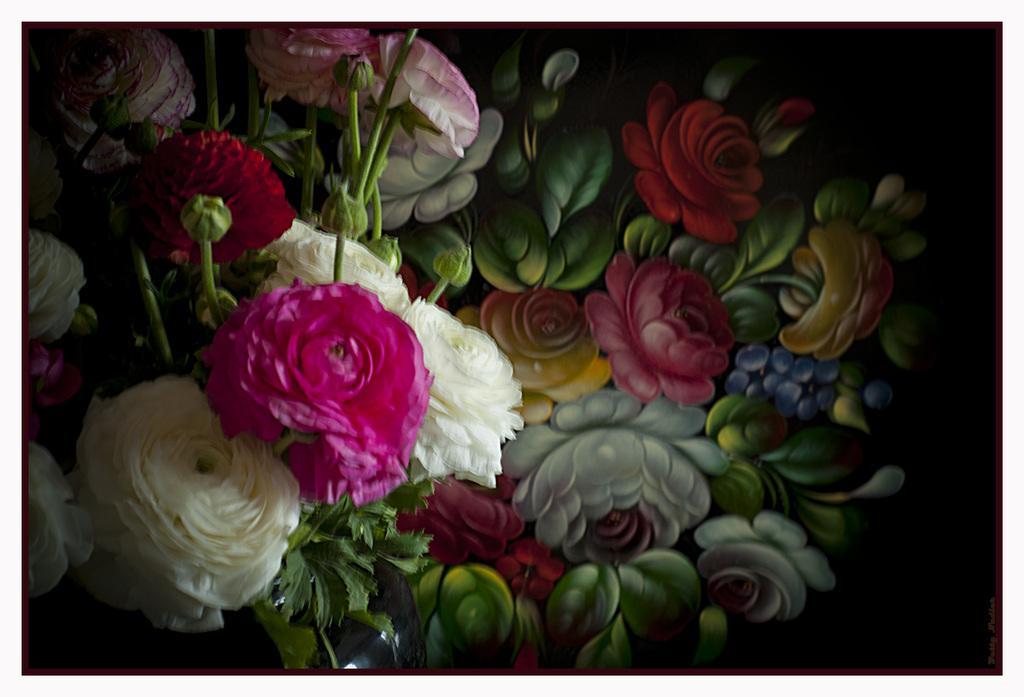How would you summarize this image in a sentence or two? In this image, we can see some flowers and buds. In the background, there is a painting. 